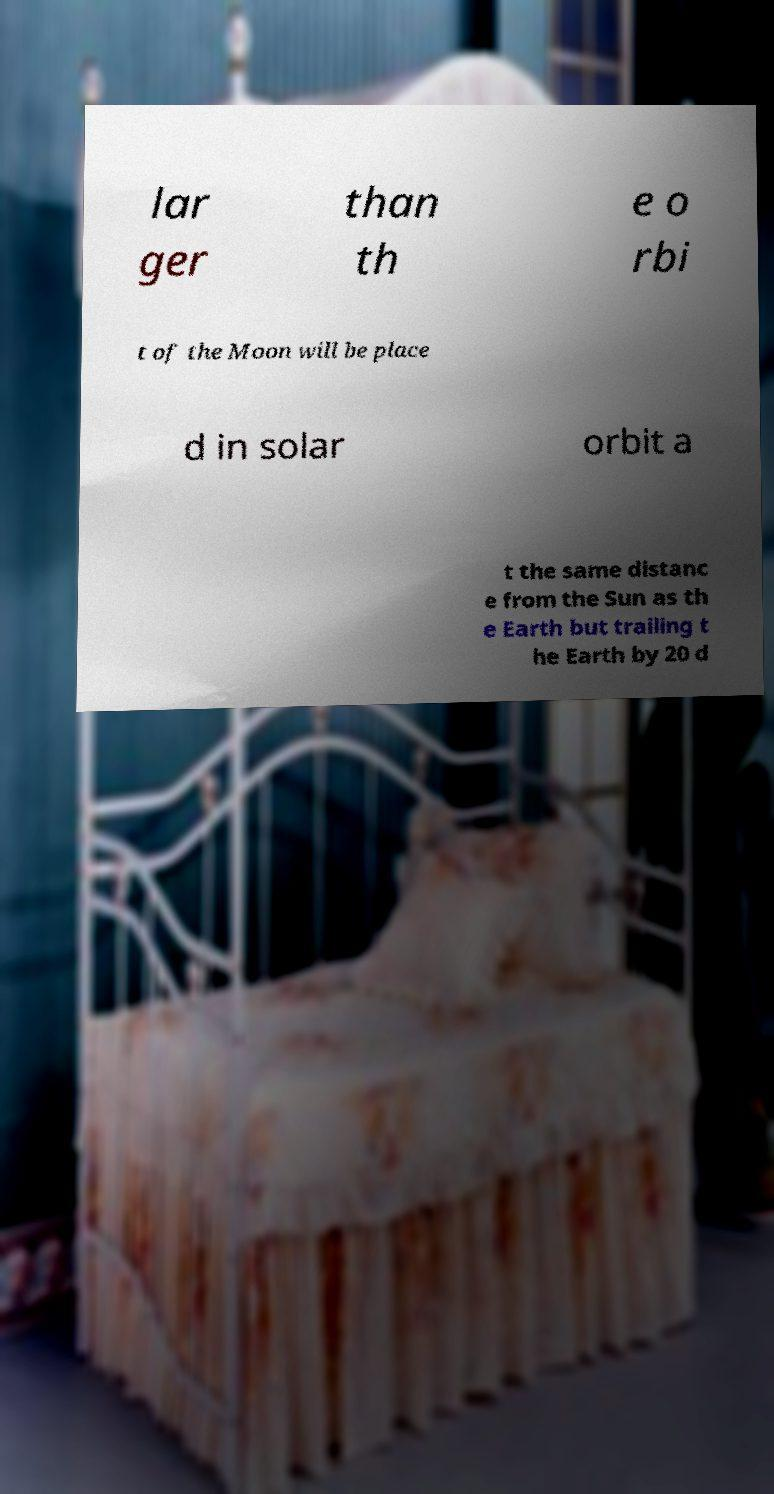Please read and relay the text visible in this image. What does it say? lar ger than th e o rbi t of the Moon will be place d in solar orbit a t the same distanc e from the Sun as th e Earth but trailing t he Earth by 20 d 